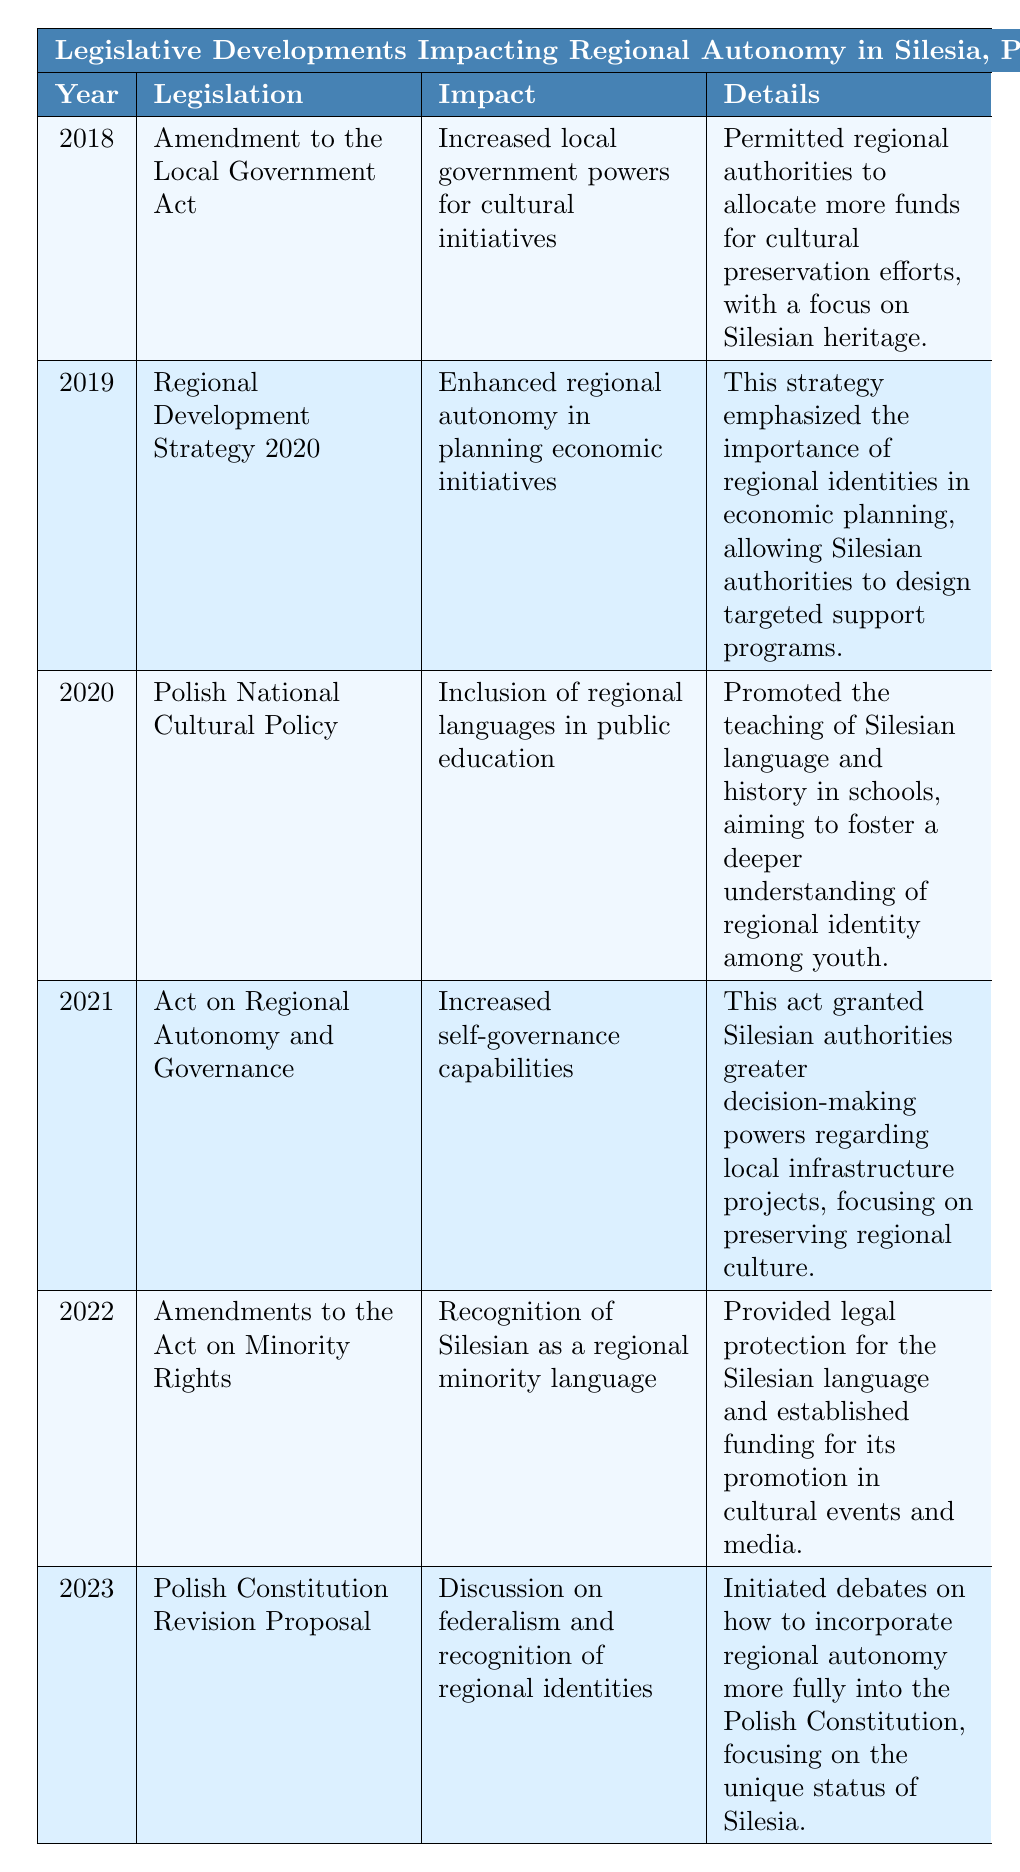What legislation was passed in 2021 impacting regional autonomy? In 2021, the "Act on Regional Autonomy and Governance" was passed. This can be identified by looking for the year 2021 in the table under the Legislation column.
Answer: Act on Regional Autonomy and Governance Which year saw the introduction of the "Polish National Cultural Policy"? By scanning the Year column, we find that the "Polish National Cultural Policy" was introduced in 2020.
Answer: 2020 What was the impact of the 2022 amendments to the Act on Minority Rights? The 2022 amendments recognized Silesian as a regional minority language, which is stated under the Impact column for that year.
Answer: Recognition of Silesian as a regional minority language In which year did the discussions about incorporating regional autonomy into the Polish Constitution begin? According to the table, discussions on incorporating regional autonomy began in 2023, referenced in that year's row.
Answer: 2023 How many pieces of legislation mentioned in the table included cultural initiatives? The 2018, 2020, and 2022 pieces of legislation focused on cultural initiatives or language, making a total of 3 instances identified throughout the table.
Answer: 3 Was the "Amendment to the Local Government Act" focused on increasing economic initiatives? The Amendment to the Local Government Act in 2018 aimed at increasing local government powers for cultural initiatives, not economic initiatives, which can be confirmed by referring to its Impact description.
Answer: No Which legislation specifically mentioned funding for cultural preservation in Silesia? The legislation titled "Amendment to the Local Government Act" in 2018 mentioned allocating more funds for cultural preservation efforts, as stated in its Details.
Answer: Amendment to the Local Government Act Compare the impacts of legislation from 2019 and 2021. The 2019 legislation enhanced regional autonomy in planning economic initiatives while the 2021 legislation increased self-governance capabilities. Therefore, the 2019 focuses on economic identity versus the 2021's focus on governance.
Answer: 2019: enhanced economic initiatives; 2021: increased self-governance What legal protection was established for the Silesian language? The 2022 amendments to the Act on Minority Rights provided legal protection for the Silesian language, as specified under the Details column for that year.
Answer: Legal protection for the Silesian language Identify the two legislative initiatives that had a direct impact on education. The "Polish National Cultural Policy" from 2020 focused on regional languages in public education, and no other legislation directly addresses education, so it is the only one regarding educational impacts.
Answer: Polish National Cultural Policy What is the trend of legislative developments in relation to cultural and regional identity in Silesia over the years? By examining the table from 2018 to 2023, all pieces of legislation show a consistent trend of increasing support for cultural and regional identity through varied impacts such as funding, language recognition, and governance.
Answer: Increasing support for cultural and regional identity 